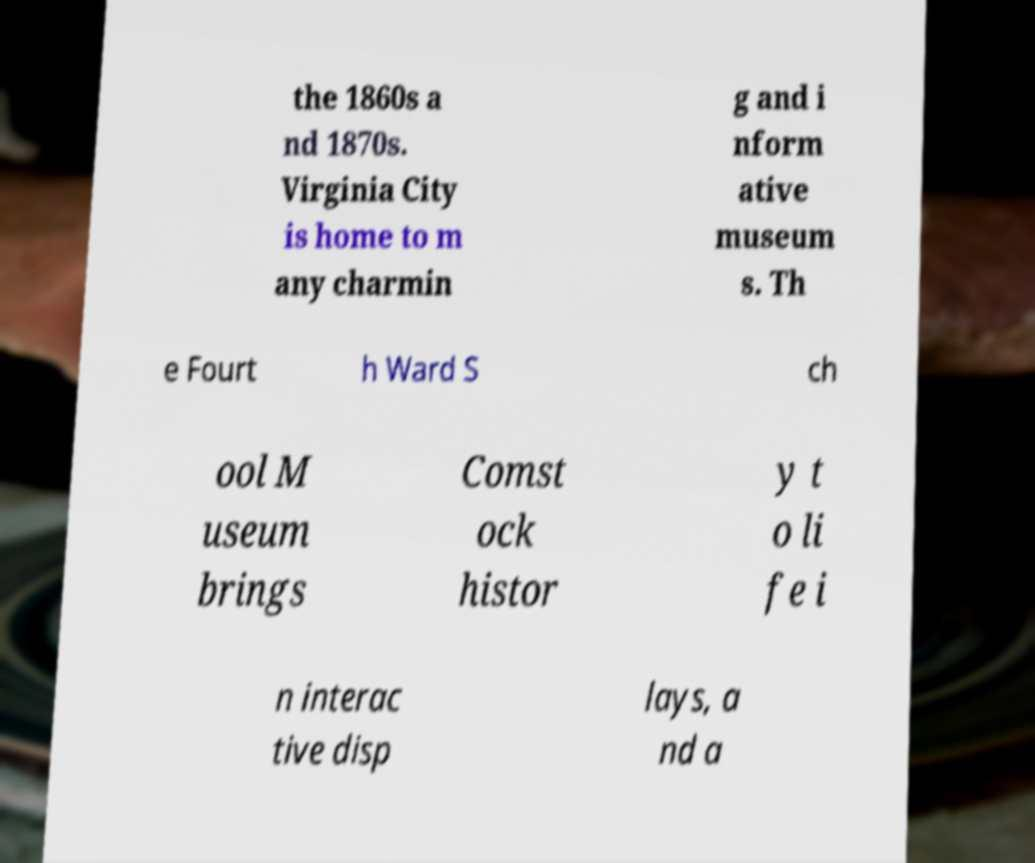Can you accurately transcribe the text from the provided image for me? the 1860s a nd 1870s. Virginia City is home to m any charmin g and i nform ative museum s. Th e Fourt h Ward S ch ool M useum brings Comst ock histor y t o li fe i n interac tive disp lays, a nd a 